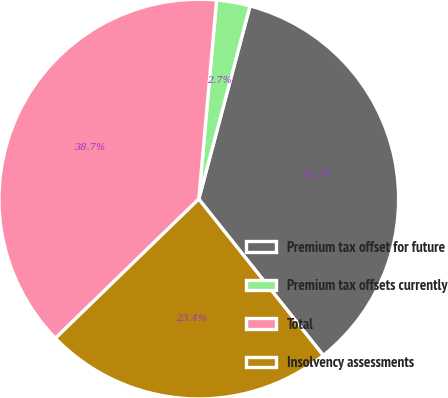Convert chart. <chart><loc_0><loc_0><loc_500><loc_500><pie_chart><fcel>Premium tax offset for future<fcel>Premium tax offsets currently<fcel>Total<fcel>Insolvency assessments<nl><fcel>35.17%<fcel>2.71%<fcel>38.68%<fcel>23.44%<nl></chart> 